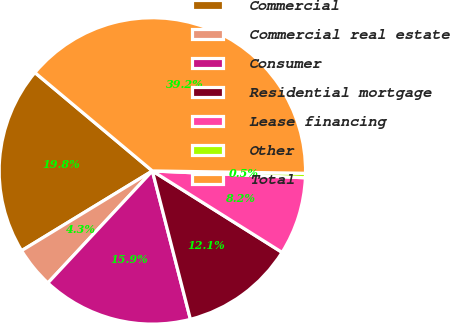<chart> <loc_0><loc_0><loc_500><loc_500><pie_chart><fcel>Commercial<fcel>Commercial real estate<fcel>Consumer<fcel>Residential mortgage<fcel>Lease financing<fcel>Other<fcel>Total<nl><fcel>19.81%<fcel>4.34%<fcel>15.94%<fcel>12.08%<fcel>8.21%<fcel>0.47%<fcel>39.15%<nl></chart> 